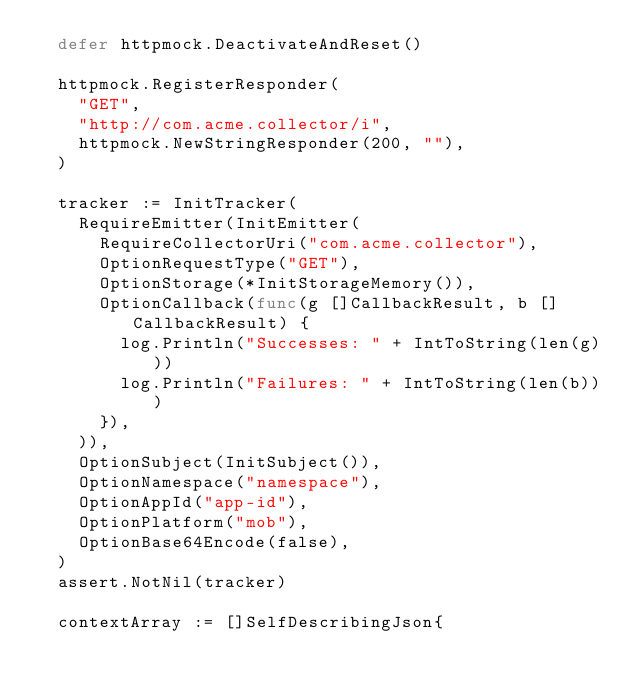<code> <loc_0><loc_0><loc_500><loc_500><_Go_>	defer httpmock.DeactivateAndReset()

	httpmock.RegisterResponder(
		"GET",
		"http://com.acme.collector/i",
		httpmock.NewStringResponder(200, ""),
	)

	tracker := InitTracker(
		RequireEmitter(InitEmitter(
			RequireCollectorUri("com.acme.collector"),
			OptionRequestType("GET"),
			OptionStorage(*InitStorageMemory()),
			OptionCallback(func(g []CallbackResult, b []CallbackResult) {
				log.Println("Successes: " + IntToString(len(g)))
				log.Println("Failures: " + IntToString(len(b)))
			}),
		)),
		OptionSubject(InitSubject()),
		OptionNamespace("namespace"),
		OptionAppId("app-id"),
		OptionPlatform("mob"),
		OptionBase64Encode(false),
	)
	assert.NotNil(tracker)

	contextArray := []SelfDescribingJson{</code> 